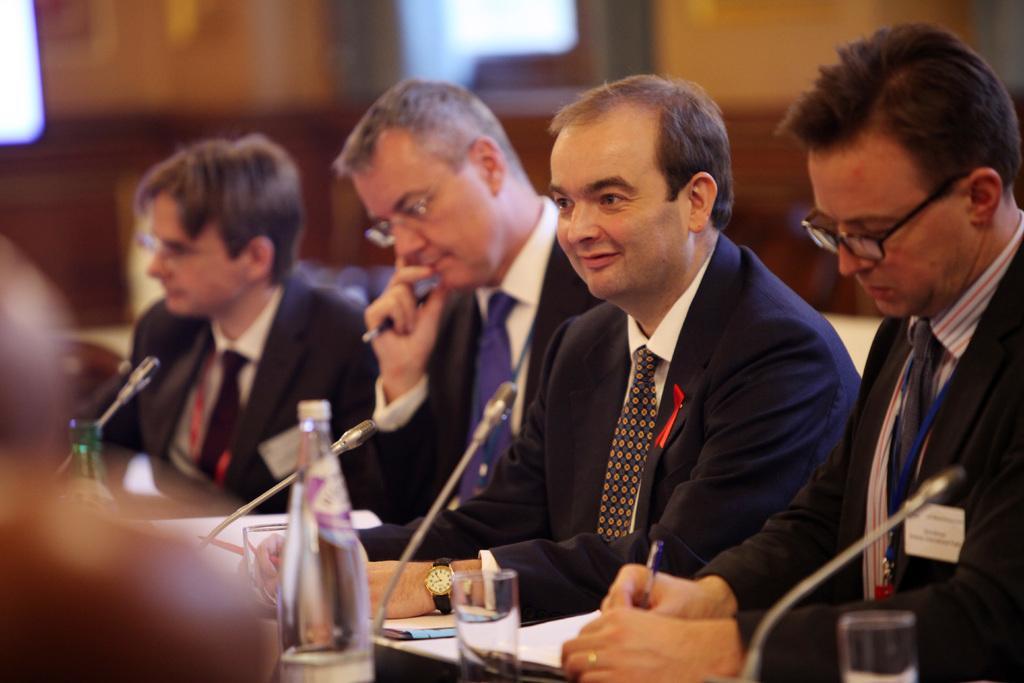Can you describe this image briefly? Here I can see four men are wearing black color suits and sitting and in front of the table. On the table I can see two bottles, glasses, some papers and microphones are attached to it. In the background there is a wall. 